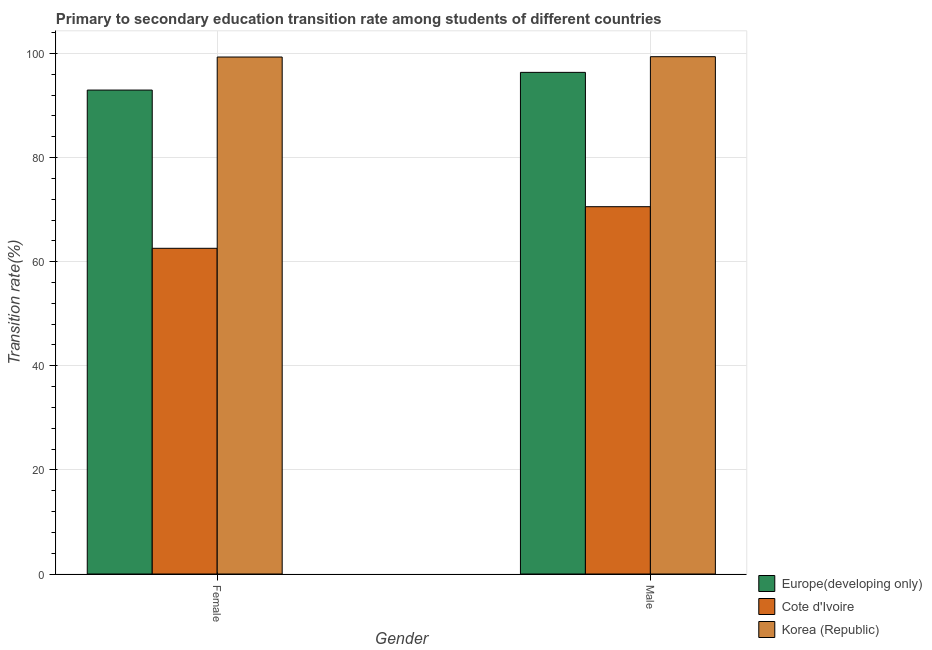How many different coloured bars are there?
Offer a terse response. 3. How many groups of bars are there?
Make the answer very short. 2. Are the number of bars per tick equal to the number of legend labels?
Your response must be concise. Yes. Are the number of bars on each tick of the X-axis equal?
Your answer should be compact. Yes. How many bars are there on the 1st tick from the left?
Give a very brief answer. 3. How many bars are there on the 1st tick from the right?
Your answer should be very brief. 3. What is the label of the 1st group of bars from the left?
Provide a succinct answer. Female. What is the transition rate among female students in Korea (Republic)?
Offer a terse response. 99.31. Across all countries, what is the maximum transition rate among female students?
Make the answer very short. 99.31. Across all countries, what is the minimum transition rate among male students?
Offer a terse response. 70.56. In which country was the transition rate among female students maximum?
Make the answer very short. Korea (Republic). In which country was the transition rate among female students minimum?
Ensure brevity in your answer.  Cote d'Ivoire. What is the total transition rate among female students in the graph?
Your answer should be very brief. 254.83. What is the difference between the transition rate among male students in Cote d'Ivoire and that in Korea (Republic)?
Provide a succinct answer. -28.81. What is the difference between the transition rate among male students in Cote d'Ivoire and the transition rate among female students in Europe(developing only)?
Your answer should be very brief. -22.4. What is the average transition rate among female students per country?
Keep it short and to the point. 84.94. What is the difference between the transition rate among male students and transition rate among female students in Korea (Republic)?
Your answer should be compact. 0.06. In how many countries, is the transition rate among male students greater than 24 %?
Make the answer very short. 3. What is the ratio of the transition rate among male students in Korea (Republic) to that in Europe(developing only)?
Make the answer very short. 1.03. Is the transition rate among male students in Europe(developing only) less than that in Korea (Republic)?
Ensure brevity in your answer.  Yes. In how many countries, is the transition rate among female students greater than the average transition rate among female students taken over all countries?
Provide a short and direct response. 2. What does the 3rd bar from the right in Male represents?
Your answer should be very brief. Europe(developing only). What is the difference between two consecutive major ticks on the Y-axis?
Your response must be concise. 20. Are the values on the major ticks of Y-axis written in scientific E-notation?
Keep it short and to the point. No. What is the title of the graph?
Offer a terse response. Primary to secondary education transition rate among students of different countries. Does "Armenia" appear as one of the legend labels in the graph?
Give a very brief answer. No. What is the label or title of the X-axis?
Your answer should be compact. Gender. What is the label or title of the Y-axis?
Provide a succinct answer. Transition rate(%). What is the Transition rate(%) in Europe(developing only) in Female?
Offer a terse response. 92.96. What is the Transition rate(%) of Cote d'Ivoire in Female?
Your answer should be compact. 62.56. What is the Transition rate(%) in Korea (Republic) in Female?
Offer a very short reply. 99.31. What is the Transition rate(%) of Europe(developing only) in Male?
Your answer should be very brief. 96.36. What is the Transition rate(%) in Cote d'Ivoire in Male?
Provide a succinct answer. 70.56. What is the Transition rate(%) of Korea (Republic) in Male?
Your answer should be compact. 99.37. Across all Gender, what is the maximum Transition rate(%) of Europe(developing only)?
Provide a succinct answer. 96.36. Across all Gender, what is the maximum Transition rate(%) in Cote d'Ivoire?
Your answer should be compact. 70.56. Across all Gender, what is the maximum Transition rate(%) of Korea (Republic)?
Give a very brief answer. 99.37. Across all Gender, what is the minimum Transition rate(%) of Europe(developing only)?
Your answer should be very brief. 92.96. Across all Gender, what is the minimum Transition rate(%) in Cote d'Ivoire?
Your answer should be compact. 62.56. Across all Gender, what is the minimum Transition rate(%) of Korea (Republic)?
Provide a short and direct response. 99.31. What is the total Transition rate(%) of Europe(developing only) in the graph?
Your answer should be very brief. 189.32. What is the total Transition rate(%) of Cote d'Ivoire in the graph?
Your response must be concise. 133.12. What is the total Transition rate(%) of Korea (Republic) in the graph?
Give a very brief answer. 198.68. What is the difference between the Transition rate(%) in Europe(developing only) in Female and that in Male?
Your answer should be compact. -3.4. What is the difference between the Transition rate(%) of Cote d'Ivoire in Female and that in Male?
Your answer should be very brief. -7.99. What is the difference between the Transition rate(%) of Korea (Republic) in Female and that in Male?
Give a very brief answer. -0.06. What is the difference between the Transition rate(%) of Europe(developing only) in Female and the Transition rate(%) of Cote d'Ivoire in Male?
Provide a short and direct response. 22.4. What is the difference between the Transition rate(%) of Europe(developing only) in Female and the Transition rate(%) of Korea (Republic) in Male?
Offer a very short reply. -6.41. What is the difference between the Transition rate(%) in Cote d'Ivoire in Female and the Transition rate(%) in Korea (Republic) in Male?
Provide a short and direct response. -36.81. What is the average Transition rate(%) of Europe(developing only) per Gender?
Offer a terse response. 94.66. What is the average Transition rate(%) of Cote d'Ivoire per Gender?
Provide a succinct answer. 66.56. What is the average Transition rate(%) of Korea (Republic) per Gender?
Offer a terse response. 99.34. What is the difference between the Transition rate(%) of Europe(developing only) and Transition rate(%) of Cote d'Ivoire in Female?
Offer a terse response. 30.4. What is the difference between the Transition rate(%) in Europe(developing only) and Transition rate(%) in Korea (Republic) in Female?
Keep it short and to the point. -6.35. What is the difference between the Transition rate(%) in Cote d'Ivoire and Transition rate(%) in Korea (Republic) in Female?
Ensure brevity in your answer.  -36.74. What is the difference between the Transition rate(%) in Europe(developing only) and Transition rate(%) in Cote d'Ivoire in Male?
Provide a short and direct response. 25.8. What is the difference between the Transition rate(%) in Europe(developing only) and Transition rate(%) in Korea (Republic) in Male?
Provide a succinct answer. -3.01. What is the difference between the Transition rate(%) of Cote d'Ivoire and Transition rate(%) of Korea (Republic) in Male?
Offer a terse response. -28.81. What is the ratio of the Transition rate(%) in Europe(developing only) in Female to that in Male?
Your answer should be compact. 0.96. What is the ratio of the Transition rate(%) of Cote d'Ivoire in Female to that in Male?
Provide a short and direct response. 0.89. What is the ratio of the Transition rate(%) of Korea (Republic) in Female to that in Male?
Your response must be concise. 1. What is the difference between the highest and the second highest Transition rate(%) of Europe(developing only)?
Provide a short and direct response. 3.4. What is the difference between the highest and the second highest Transition rate(%) in Cote d'Ivoire?
Offer a terse response. 7.99. What is the difference between the highest and the second highest Transition rate(%) of Korea (Republic)?
Offer a terse response. 0.06. What is the difference between the highest and the lowest Transition rate(%) of Europe(developing only)?
Keep it short and to the point. 3.4. What is the difference between the highest and the lowest Transition rate(%) in Cote d'Ivoire?
Make the answer very short. 7.99. What is the difference between the highest and the lowest Transition rate(%) in Korea (Republic)?
Your response must be concise. 0.06. 